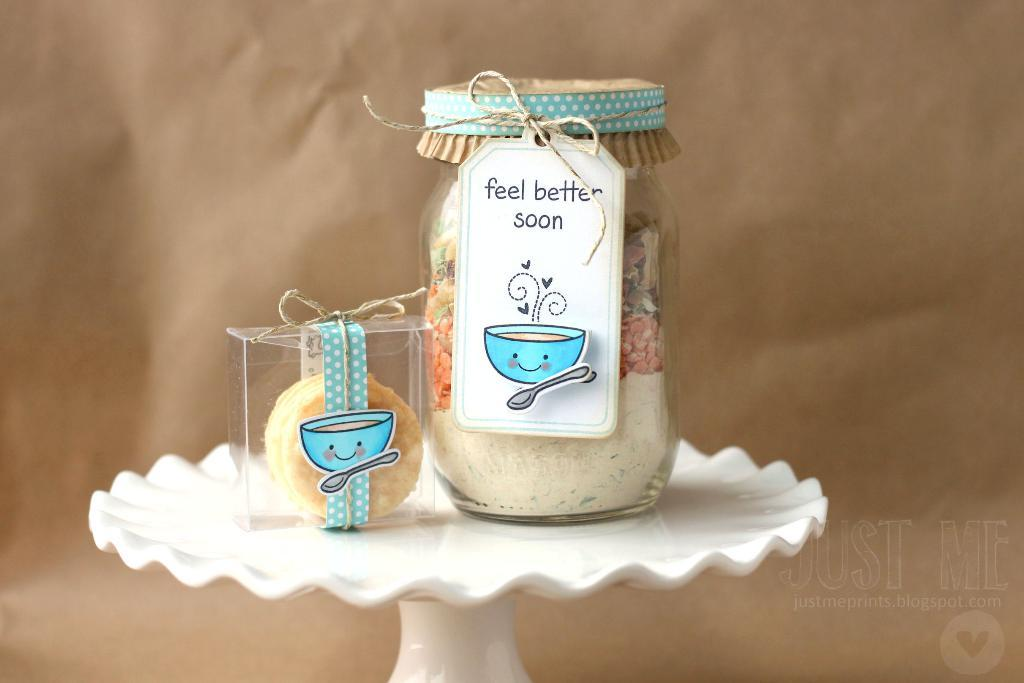<image>
Write a terse but informative summary of the picture. a cake plate holds a gift with a feel better soon sign 